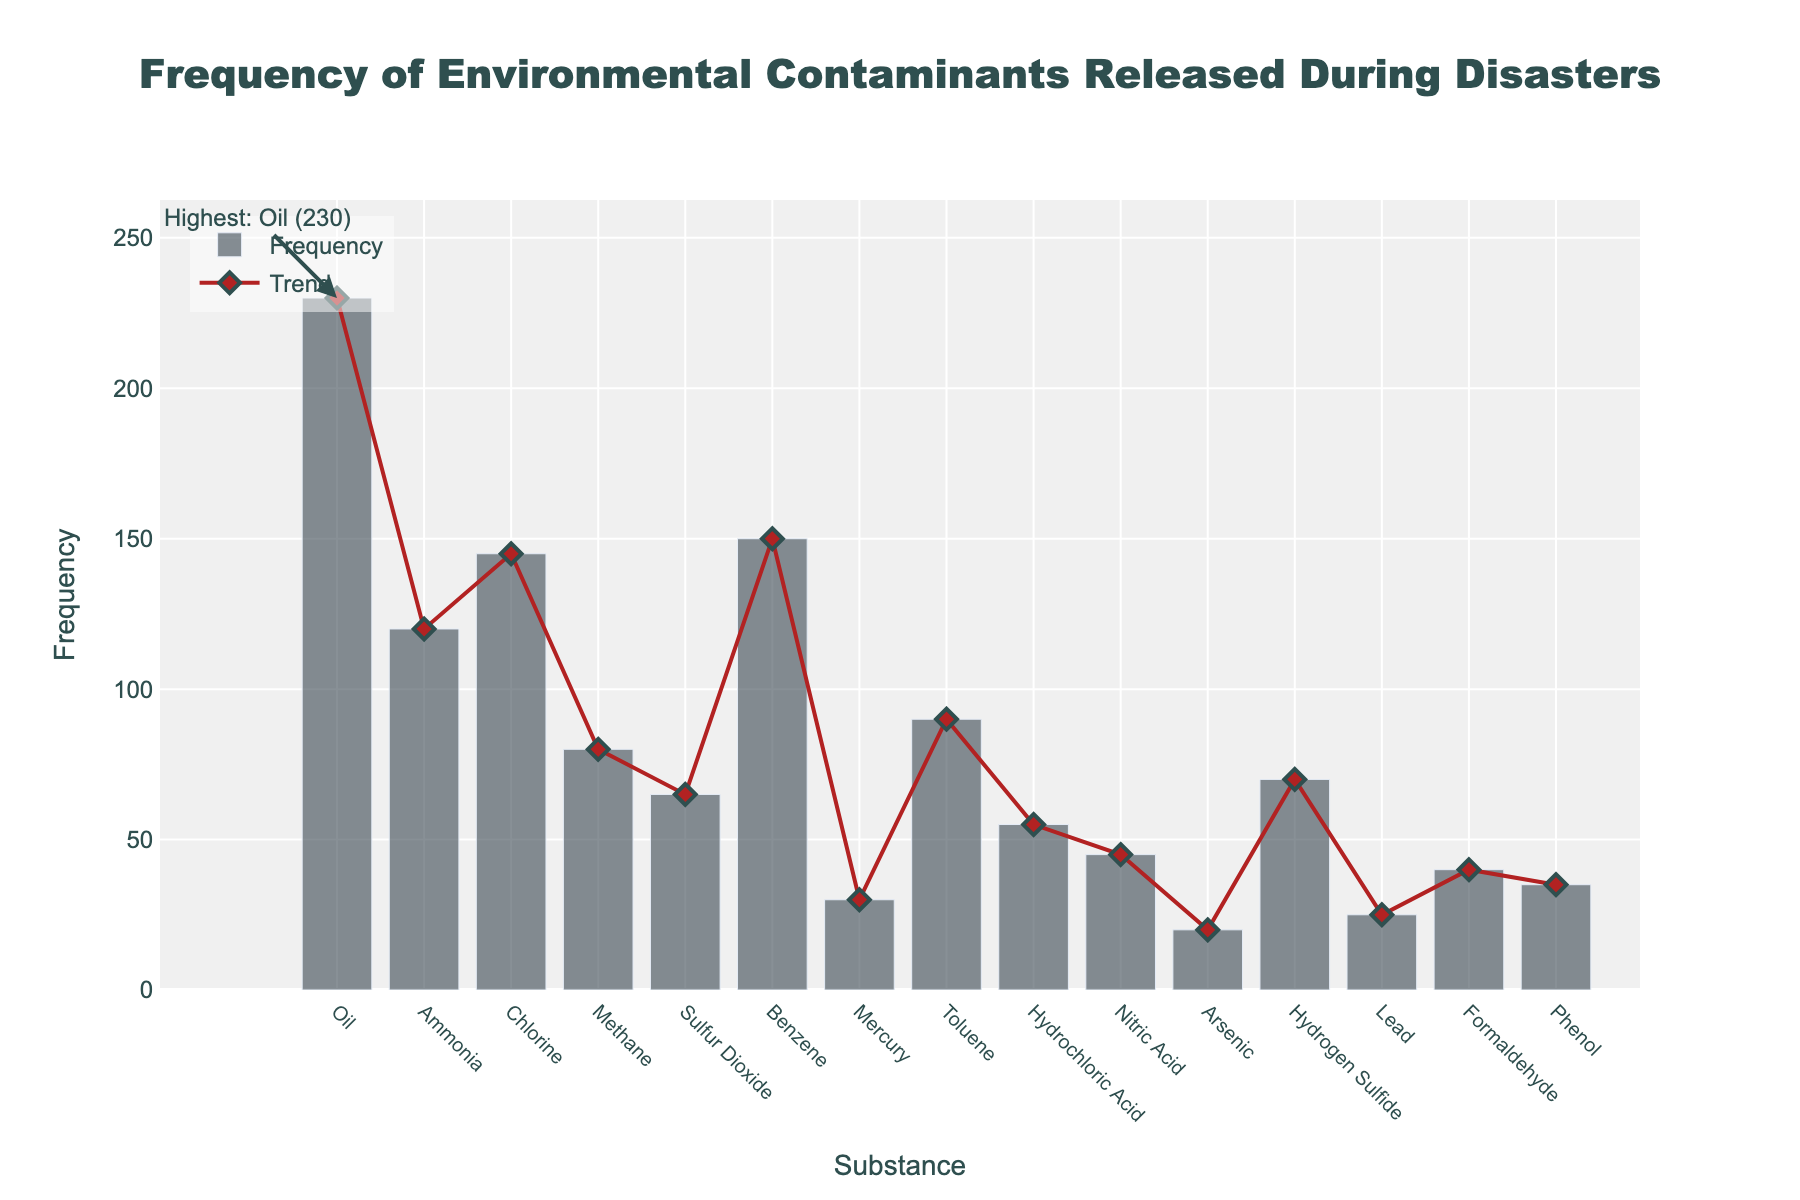What is the title of the figure? The title of the figure is positioned at the top center and reads 'Frequency of Environmental Contaminants Released During Disasters'.
Answer: Frequency of Environmental Contaminants Released During Disasters Which substance has the highest frequency of release during disasters? The highest frequency is highlighted with an annotation in the figure, indicating both the substance and its frequency. The substance with the highest frequency is Oil, with a frequency of 230.
Answer: Oil What is the total frequency of Chlorine and Benzene releases? The frequencies of Chlorine and Benzene can be found by looking at their respective bars. Chlorine has a frequency of 145, and Benzene has a frequency of 150. Adding these together: 145 + 150 = 295.
Answer: 295 Is the frequency of Lead releases higher or lower than that of Mercury? By comparing the heights of the bars for Lead and Mercury, we see that Lead has a frequency of 25 while Mercury has a frequency of 30. Lead's frequency is lower than Mercury's.
Answer: Lower What is the difference in frequency between Methane and Toluene releases? Methane has a frequency of 80, and Toluene has a frequency of 90. The difference is calculated as 90 - 80 = 10.
Answer: 10 Which substances have a frequency of release less than 50? The bars for substances with frequencies less than 50 are shorter in height. Arsenic (20), Lead (25), Formaldehyde (40), and Phenol (35) all meet this criterion.
Answer: Arsenic, Lead, Formaldehyde, Phenol How does the frequency of Oil releases compare to the sum of Hydrochloric Acid and Nitric Acid releases? Oil has a frequency of 230. Hydrochloric Acid has a frequency of 55, and Nitric Acid has 45. Their sum is 55 + 45 = 100. Oil's frequency is greater than this sum (230 > 100).
Answer: Greater What is the average frequency of all the substances released? Sum the frequencies of all substances (230+120+145+80+65+150+30+90+55+45+20+70+25+40+35 = 1170). There are 15 substances, so the average frequency is 1170 / 15 = 78.
Answer: 78 Which substance has the lowest frequency of release during disasters? The shortest bar on the figure represents the substance with the lowest frequency. This substance is Arsenic, which has a frequency of 20.
Answer: Arsenic What trends are evident in the frequency of substances released? The scatter plot line indicates some trends. Higher frequencies appear for volatile and widely-used substances like Oil and Benzene, while toxic heavy metals like Mercury and Lead are less frequently released. This trend suggests industrial processes play a role in environmental releases.
Answer: Widely-used substances have higher releases, while toxic heavy metals have lower releases 